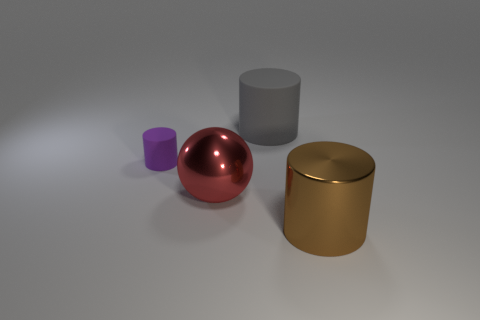Is there any other thing that is the same size as the purple thing? It's difficult to ascertain the exact sizes from this perspective, but the red sphere appears to be larger than the purple cylinder, and the other objects also have different dimensions. Size comparisons in images like this can be deceptive without a common reference point. 